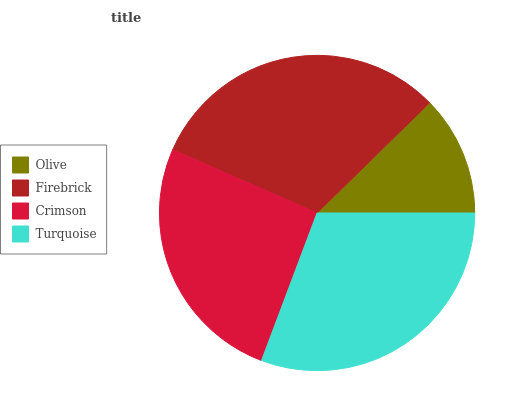Is Olive the minimum?
Answer yes or no. Yes. Is Firebrick the maximum?
Answer yes or no. Yes. Is Crimson the minimum?
Answer yes or no. No. Is Crimson the maximum?
Answer yes or no. No. Is Firebrick greater than Crimson?
Answer yes or no. Yes. Is Crimson less than Firebrick?
Answer yes or no. Yes. Is Crimson greater than Firebrick?
Answer yes or no. No. Is Firebrick less than Crimson?
Answer yes or no. No. Is Turquoise the high median?
Answer yes or no. Yes. Is Crimson the low median?
Answer yes or no. Yes. Is Firebrick the high median?
Answer yes or no. No. Is Firebrick the low median?
Answer yes or no. No. 